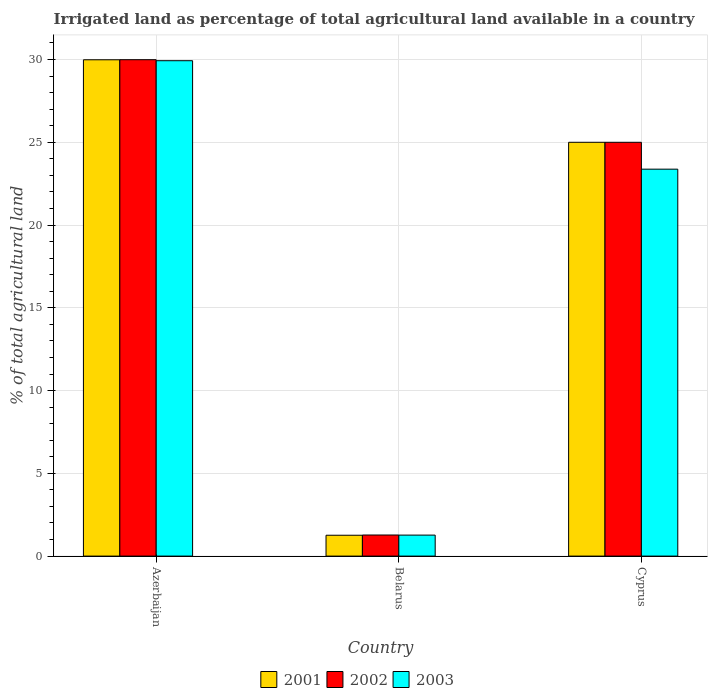Are the number of bars per tick equal to the number of legend labels?
Keep it short and to the point. Yes. How many bars are there on the 2nd tick from the left?
Make the answer very short. 3. What is the label of the 3rd group of bars from the left?
Provide a short and direct response. Cyprus. In how many cases, is the number of bars for a given country not equal to the number of legend labels?
Your answer should be compact. 0. What is the percentage of irrigated land in 2003 in Azerbaijan?
Keep it short and to the point. 29.93. Across all countries, what is the maximum percentage of irrigated land in 2003?
Your answer should be compact. 29.93. Across all countries, what is the minimum percentage of irrigated land in 2003?
Give a very brief answer. 1.27. In which country was the percentage of irrigated land in 2002 maximum?
Provide a succinct answer. Azerbaijan. In which country was the percentage of irrigated land in 2003 minimum?
Offer a terse response. Belarus. What is the total percentage of irrigated land in 2003 in the graph?
Provide a short and direct response. 54.57. What is the difference between the percentage of irrigated land in 2002 in Belarus and that in Cyprus?
Offer a very short reply. -23.73. What is the difference between the percentage of irrigated land in 2003 in Cyprus and the percentage of irrigated land in 2001 in Azerbaijan?
Provide a succinct answer. -6.61. What is the average percentage of irrigated land in 2003 per country?
Provide a succinct answer. 18.19. What is the difference between the percentage of irrigated land of/in 2001 and percentage of irrigated land of/in 2002 in Cyprus?
Your answer should be compact. 0. What is the ratio of the percentage of irrigated land in 2002 in Belarus to that in Cyprus?
Provide a short and direct response. 0.05. Is the difference between the percentage of irrigated land in 2001 in Belarus and Cyprus greater than the difference between the percentage of irrigated land in 2002 in Belarus and Cyprus?
Offer a terse response. No. What is the difference between the highest and the second highest percentage of irrigated land in 2003?
Keep it short and to the point. -28.66. What is the difference between the highest and the lowest percentage of irrigated land in 2001?
Provide a succinct answer. 28.73. In how many countries, is the percentage of irrigated land in 2001 greater than the average percentage of irrigated land in 2001 taken over all countries?
Keep it short and to the point. 2. Is the sum of the percentage of irrigated land in 2002 in Belarus and Cyprus greater than the maximum percentage of irrigated land in 2001 across all countries?
Your answer should be compact. No. Are all the bars in the graph horizontal?
Keep it short and to the point. No. How many countries are there in the graph?
Your response must be concise. 3. Does the graph contain any zero values?
Offer a very short reply. No. Does the graph contain grids?
Your answer should be compact. Yes. How many legend labels are there?
Ensure brevity in your answer.  3. How are the legend labels stacked?
Provide a short and direct response. Horizontal. What is the title of the graph?
Your answer should be compact. Irrigated land as percentage of total agricultural land available in a country. What is the label or title of the X-axis?
Provide a short and direct response. Country. What is the label or title of the Y-axis?
Provide a succinct answer. % of total agricultural land. What is the % of total agricultural land in 2001 in Azerbaijan?
Provide a short and direct response. 29.99. What is the % of total agricultural land in 2002 in Azerbaijan?
Give a very brief answer. 29.99. What is the % of total agricultural land of 2003 in Azerbaijan?
Make the answer very short. 29.93. What is the % of total agricultural land of 2001 in Belarus?
Keep it short and to the point. 1.26. What is the % of total agricultural land in 2002 in Belarus?
Offer a terse response. 1.27. What is the % of total agricultural land in 2003 in Belarus?
Offer a terse response. 1.27. What is the % of total agricultural land of 2001 in Cyprus?
Make the answer very short. 25. What is the % of total agricultural land of 2003 in Cyprus?
Keep it short and to the point. 23.38. Across all countries, what is the maximum % of total agricultural land of 2001?
Your answer should be very brief. 29.99. Across all countries, what is the maximum % of total agricultural land in 2002?
Keep it short and to the point. 29.99. Across all countries, what is the maximum % of total agricultural land of 2003?
Your response must be concise. 29.93. Across all countries, what is the minimum % of total agricultural land in 2001?
Provide a short and direct response. 1.26. Across all countries, what is the minimum % of total agricultural land in 2002?
Your response must be concise. 1.27. Across all countries, what is the minimum % of total agricultural land of 2003?
Give a very brief answer. 1.27. What is the total % of total agricultural land in 2001 in the graph?
Your answer should be very brief. 56.25. What is the total % of total agricultural land of 2002 in the graph?
Keep it short and to the point. 56.26. What is the total % of total agricultural land in 2003 in the graph?
Keep it short and to the point. 54.57. What is the difference between the % of total agricultural land in 2001 in Azerbaijan and that in Belarus?
Offer a terse response. 28.73. What is the difference between the % of total agricultural land in 2002 in Azerbaijan and that in Belarus?
Your answer should be compact. 28.72. What is the difference between the % of total agricultural land in 2003 in Azerbaijan and that in Belarus?
Give a very brief answer. 28.66. What is the difference between the % of total agricultural land of 2001 in Azerbaijan and that in Cyprus?
Ensure brevity in your answer.  4.99. What is the difference between the % of total agricultural land of 2002 in Azerbaijan and that in Cyprus?
Make the answer very short. 4.99. What is the difference between the % of total agricultural land of 2003 in Azerbaijan and that in Cyprus?
Offer a very short reply. 6.55. What is the difference between the % of total agricultural land in 2001 in Belarus and that in Cyprus?
Offer a very short reply. -23.74. What is the difference between the % of total agricultural land in 2002 in Belarus and that in Cyprus?
Ensure brevity in your answer.  -23.73. What is the difference between the % of total agricultural land of 2003 in Belarus and that in Cyprus?
Your answer should be very brief. -22.11. What is the difference between the % of total agricultural land in 2001 in Azerbaijan and the % of total agricultural land in 2002 in Belarus?
Provide a succinct answer. 28.71. What is the difference between the % of total agricultural land of 2001 in Azerbaijan and the % of total agricultural land of 2003 in Belarus?
Give a very brief answer. 28.72. What is the difference between the % of total agricultural land in 2002 in Azerbaijan and the % of total agricultural land in 2003 in Belarus?
Offer a terse response. 28.72. What is the difference between the % of total agricultural land of 2001 in Azerbaijan and the % of total agricultural land of 2002 in Cyprus?
Ensure brevity in your answer.  4.99. What is the difference between the % of total agricultural land in 2001 in Azerbaijan and the % of total agricultural land in 2003 in Cyprus?
Ensure brevity in your answer.  6.61. What is the difference between the % of total agricultural land in 2002 in Azerbaijan and the % of total agricultural land in 2003 in Cyprus?
Your answer should be compact. 6.61. What is the difference between the % of total agricultural land in 2001 in Belarus and the % of total agricultural land in 2002 in Cyprus?
Your answer should be compact. -23.74. What is the difference between the % of total agricultural land in 2001 in Belarus and the % of total agricultural land in 2003 in Cyprus?
Provide a succinct answer. -22.12. What is the difference between the % of total agricultural land of 2002 in Belarus and the % of total agricultural land of 2003 in Cyprus?
Your answer should be compact. -22.1. What is the average % of total agricultural land of 2001 per country?
Your answer should be compact. 18.75. What is the average % of total agricultural land of 2002 per country?
Offer a terse response. 18.75. What is the average % of total agricultural land of 2003 per country?
Your answer should be compact. 18.19. What is the difference between the % of total agricultural land in 2001 and % of total agricultural land in 2002 in Azerbaijan?
Provide a short and direct response. -0. What is the difference between the % of total agricultural land in 2001 and % of total agricultural land in 2003 in Azerbaijan?
Your response must be concise. 0.06. What is the difference between the % of total agricultural land in 2002 and % of total agricultural land in 2003 in Azerbaijan?
Provide a short and direct response. 0.06. What is the difference between the % of total agricultural land of 2001 and % of total agricultural land of 2002 in Belarus?
Provide a short and direct response. -0.01. What is the difference between the % of total agricultural land in 2001 and % of total agricultural land in 2003 in Belarus?
Provide a short and direct response. -0.01. What is the difference between the % of total agricultural land in 2002 and % of total agricultural land in 2003 in Belarus?
Provide a succinct answer. 0.01. What is the difference between the % of total agricultural land of 2001 and % of total agricultural land of 2003 in Cyprus?
Give a very brief answer. 1.62. What is the difference between the % of total agricultural land in 2002 and % of total agricultural land in 2003 in Cyprus?
Your answer should be compact. 1.62. What is the ratio of the % of total agricultural land of 2001 in Azerbaijan to that in Belarus?
Provide a succinct answer. 23.8. What is the ratio of the % of total agricultural land in 2002 in Azerbaijan to that in Belarus?
Provide a short and direct response. 23.54. What is the ratio of the % of total agricultural land of 2003 in Azerbaijan to that in Belarus?
Ensure brevity in your answer.  23.59. What is the ratio of the % of total agricultural land of 2001 in Azerbaijan to that in Cyprus?
Offer a very short reply. 1.2. What is the ratio of the % of total agricultural land of 2002 in Azerbaijan to that in Cyprus?
Keep it short and to the point. 1.2. What is the ratio of the % of total agricultural land of 2003 in Azerbaijan to that in Cyprus?
Give a very brief answer. 1.28. What is the ratio of the % of total agricultural land in 2001 in Belarus to that in Cyprus?
Provide a short and direct response. 0.05. What is the ratio of the % of total agricultural land of 2002 in Belarus to that in Cyprus?
Your response must be concise. 0.05. What is the ratio of the % of total agricultural land in 2003 in Belarus to that in Cyprus?
Offer a very short reply. 0.05. What is the difference between the highest and the second highest % of total agricultural land of 2001?
Ensure brevity in your answer.  4.99. What is the difference between the highest and the second highest % of total agricultural land of 2002?
Give a very brief answer. 4.99. What is the difference between the highest and the second highest % of total agricultural land in 2003?
Offer a terse response. 6.55. What is the difference between the highest and the lowest % of total agricultural land of 2001?
Provide a succinct answer. 28.73. What is the difference between the highest and the lowest % of total agricultural land in 2002?
Give a very brief answer. 28.72. What is the difference between the highest and the lowest % of total agricultural land of 2003?
Your answer should be very brief. 28.66. 